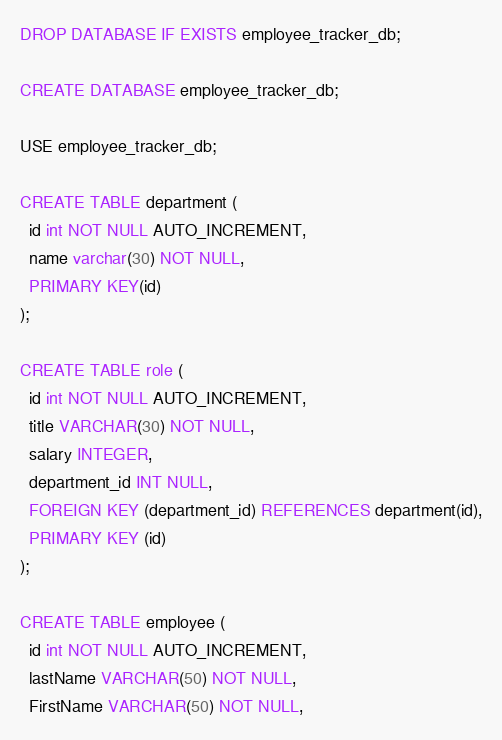<code> <loc_0><loc_0><loc_500><loc_500><_SQL_>DROP DATABASE IF EXISTS employee_tracker_db;

CREATE DATABASE employee_tracker_db;

USE employee_tracker_db;

CREATE TABLE department (
  id int NOT NULL AUTO_INCREMENT,
  name varchar(30) NOT NULL,
  PRIMARY KEY(id)
);

CREATE TABLE role (
  id int NOT NULL AUTO_INCREMENT,
  title VARCHAR(30) NOT NULL,
  salary INTEGER,
  department_id INT NULL,
  FOREIGN KEY (department_id) REFERENCES department(id),
  PRIMARY KEY (id)
);

CREATE TABLE employee (
  id int NOT NULL AUTO_INCREMENT,
  lastName VARCHAR(50) NOT NULL,
  FirstName VARCHAR(50) NOT NULL,</code> 